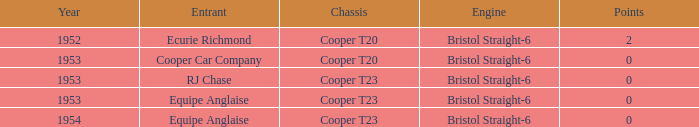Which applicant was present before 1953? Ecurie Richmond. 